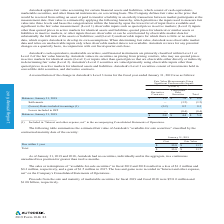According to Autodesk's financial document, What was the balance as of 31 Jan 2019 for convertible debt securities? According to the financial document, $4.4. The relevant text states: "— (0.4) (0.4) Balances, January 31, 2019 $ 0.8 $ 4.4 $ 5.2..." Also, What level(s) are Autodesk's cash equivalents, marketable securities, and financial instruments classified as? Autodesk's cash equivalents, marketable securities, and financial instruments are primarily classified within Level 1 or Level 2 of the fair value hierarchy.. The document states: "Autodesk's cash equivalents, marketable securities, and financial instruments are primarily classified within Level 1 or Level 2 of the fair value hie..." Also, How often does Autodesk review for changes? Autodesk reviews for any potential changes on a quarterly basis, in conjunction with our fiscal quarter-end close.. The document states: "only when observable market data is not available. Autodesk reviews for any potential changes on a quarterly basis, in conjunction with our fiscal qua..." Also, can you calculate: Of the total balances as of January 31, 2019, what percentage came from convertible debt securities? Based on the calculation: (4.4/5.2), the result is 84.62 (percentage). This is based on the information: "4) (0.4) Balances, January 31, 2019 $ 0.8 $ 4.4 $ 5.2 — (0.4) (0.4) Balances, January 31, 2019 $ 0.8 $ 4.4 $ 5.2..." The key data points involved are: 4.4, 5.2. Also, can you calculate: What is the difference in the balances for derivative contracts for 31 January 2018 and 31 January 2019? Based on the calculation: 1-0.8, the result is 0.2 (in millions). This is based on the information: "in OCI — (0.4) (0.4) Balances, January 31, 2019 $ 0.8 $ 4.4 $ 5.2 in OCI — (0.4) (0.4) Balances, January 31, 2019 $ 0.8 $ 4.4 $ 5.2..." The key data points involved are: 0.8, 1. Also, can you calculate: How much does the convertible debt securities portion account for the total of change included in earnings? Based on the calculation: 0.5/0.3 , the result is 166.67 (percentage). This is based on the information: "(Losses) Gains included in earnings (1) (0.2) 0.5 0.3 Losses included in OCI — (0.4) (0.4) Balances, January 31, 2019 $ 0.8 $ 4.4 $ 5.2 .5) (Losses) Gains included in earnings (1) (0.2) 0.5 0.3 Losses..." The key data points involved are: 0.3, 0.5. 